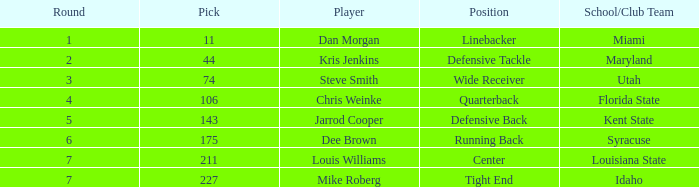At which school did steve smith receive his education? Utah. 